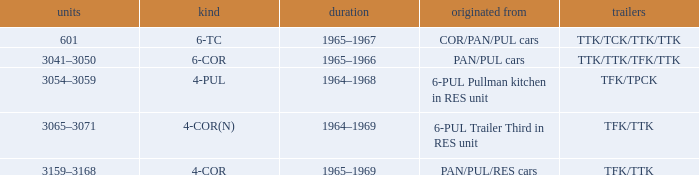Help me parse the entirety of this table. {'header': ['units', 'kind', 'duration', 'originated from', 'trailers'], 'rows': [['601', '6-TC', '1965–1967', 'COR/PAN/PUL cars', 'TTK/TCK/TTK/TTK'], ['3041–3050', '6-COR', '1965–1966', 'PAN/PUL cars', 'TTK/TTK/TFK/TTK'], ['3054–3059', '4-PUL', '1964–1968', '6-PUL Pullman kitchen in RES unit', 'TFK/TPCK'], ['3065–3071', '4-COR(N)', '1964–1969', '6-PUL Trailer Third in RES unit', 'TFK/TTK'], ['3159–3168', '4-COR', '1965–1969', 'PAN/PUL/RES cars', 'TFK/TTK']]} Name the typed for formed from 6-pul trailer third in res unit 4-COR(N). 